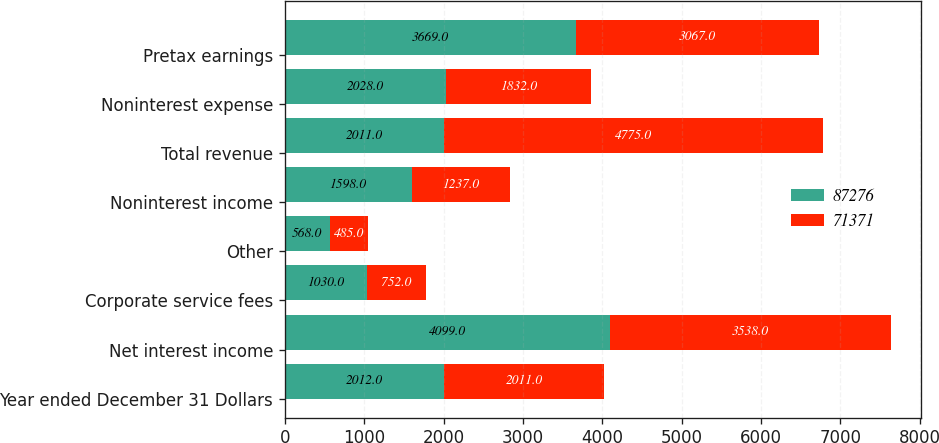Convert chart. <chart><loc_0><loc_0><loc_500><loc_500><stacked_bar_chart><ecel><fcel>Year ended December 31 Dollars<fcel>Net interest income<fcel>Corporate service fees<fcel>Other<fcel>Noninterest income<fcel>Total revenue<fcel>Noninterest expense<fcel>Pretax earnings<nl><fcel>87276<fcel>2012<fcel>4099<fcel>1030<fcel>568<fcel>1598<fcel>2011<fcel>2028<fcel>3669<nl><fcel>71371<fcel>2011<fcel>3538<fcel>752<fcel>485<fcel>1237<fcel>4775<fcel>1832<fcel>3067<nl></chart> 